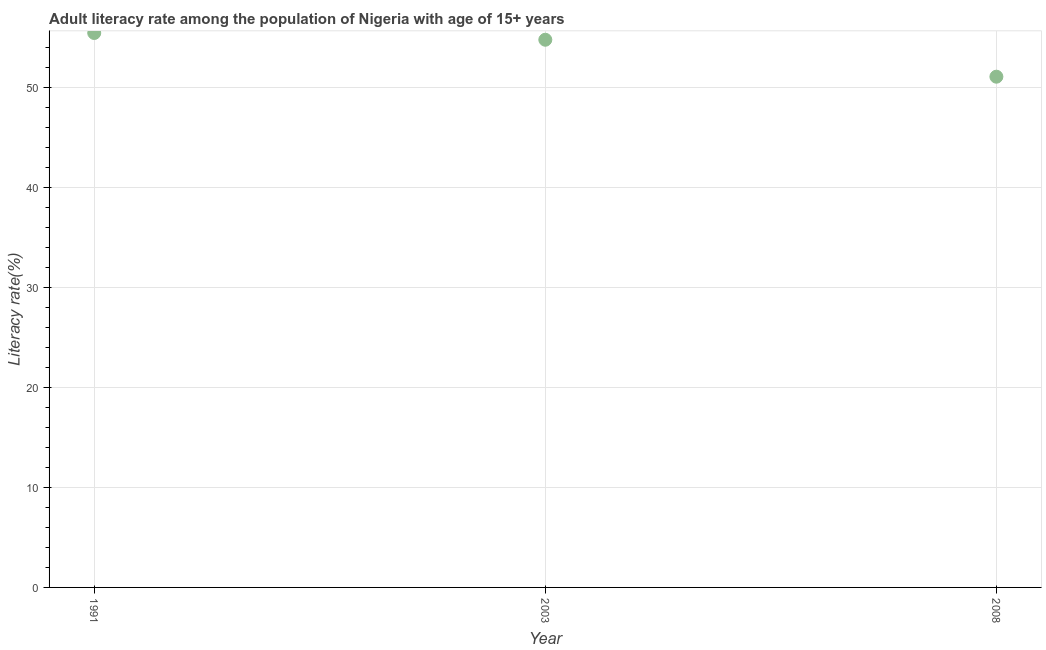What is the adult literacy rate in 2008?
Offer a very short reply. 51.08. Across all years, what is the maximum adult literacy rate?
Keep it short and to the point. 55.45. Across all years, what is the minimum adult literacy rate?
Your answer should be compact. 51.08. In which year was the adult literacy rate minimum?
Offer a very short reply. 2008. What is the sum of the adult literacy rate?
Offer a terse response. 161.3. What is the difference between the adult literacy rate in 1991 and 2003?
Your answer should be compact. 0.67. What is the average adult literacy rate per year?
Your answer should be very brief. 53.77. What is the median adult literacy rate?
Your response must be concise. 54.77. Do a majority of the years between 1991 and 2008 (inclusive) have adult literacy rate greater than 46 %?
Give a very brief answer. Yes. What is the ratio of the adult literacy rate in 1991 to that in 2003?
Your answer should be very brief. 1.01. Is the adult literacy rate in 1991 less than that in 2003?
Offer a very short reply. No. Is the difference between the adult literacy rate in 1991 and 2008 greater than the difference between any two years?
Offer a terse response. Yes. What is the difference between the highest and the second highest adult literacy rate?
Keep it short and to the point. 0.67. What is the difference between the highest and the lowest adult literacy rate?
Provide a succinct answer. 4.37. In how many years, is the adult literacy rate greater than the average adult literacy rate taken over all years?
Keep it short and to the point. 2. Does the graph contain any zero values?
Offer a terse response. No. Does the graph contain grids?
Keep it short and to the point. Yes. What is the title of the graph?
Offer a terse response. Adult literacy rate among the population of Nigeria with age of 15+ years. What is the label or title of the X-axis?
Provide a succinct answer. Year. What is the label or title of the Y-axis?
Keep it short and to the point. Literacy rate(%). What is the Literacy rate(%) in 1991?
Your answer should be compact. 55.45. What is the Literacy rate(%) in 2003?
Your answer should be very brief. 54.77. What is the Literacy rate(%) in 2008?
Provide a succinct answer. 51.08. What is the difference between the Literacy rate(%) in 1991 and 2003?
Your answer should be compact. 0.67. What is the difference between the Literacy rate(%) in 1991 and 2008?
Offer a very short reply. 4.37. What is the difference between the Literacy rate(%) in 2003 and 2008?
Provide a short and direct response. 3.7. What is the ratio of the Literacy rate(%) in 1991 to that in 2008?
Offer a very short reply. 1.09. What is the ratio of the Literacy rate(%) in 2003 to that in 2008?
Keep it short and to the point. 1.07. 